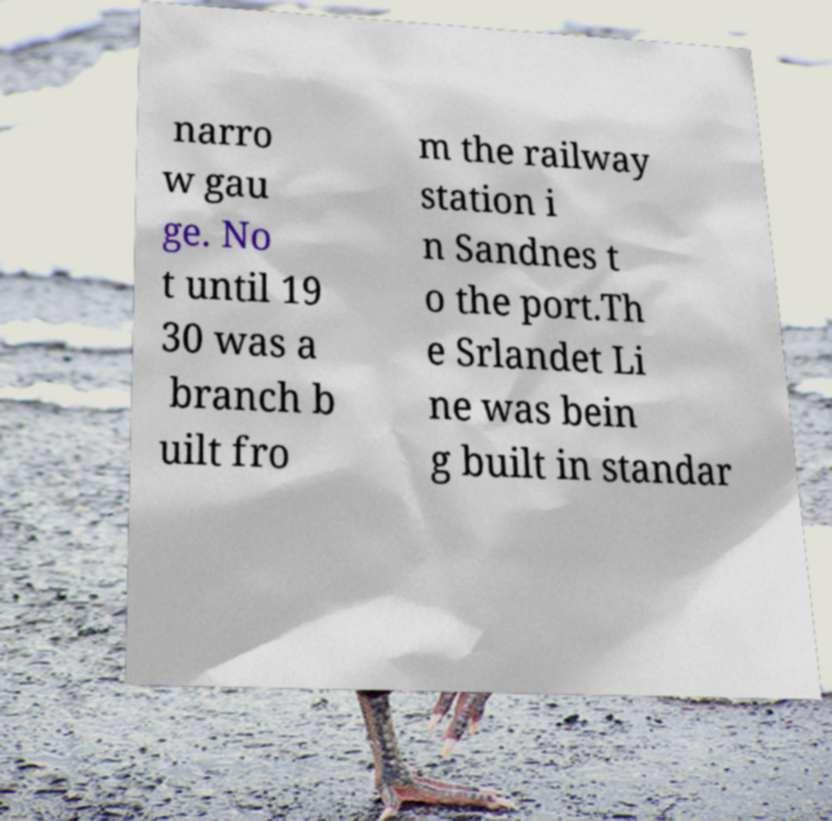There's text embedded in this image that I need extracted. Can you transcribe it verbatim? narro w gau ge. No t until 19 30 was a branch b uilt fro m the railway station i n Sandnes t o the port.Th e Srlandet Li ne was bein g built in standar 